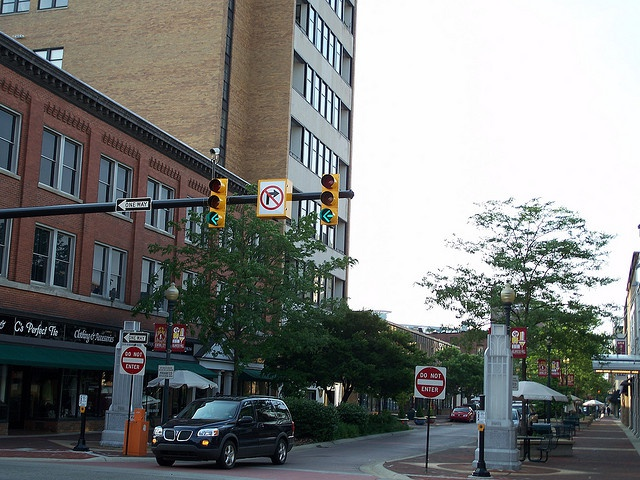Describe the objects in this image and their specific colors. I can see car in gray, black, and blue tones, traffic light in gray, black, olive, orange, and tan tones, umbrella in gray and black tones, umbrella in gray, darkgray, and black tones, and car in gray, black, and purple tones in this image. 